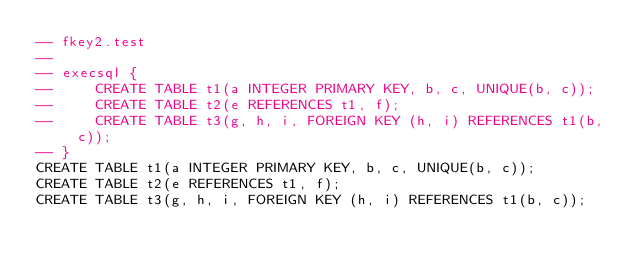<code> <loc_0><loc_0><loc_500><loc_500><_SQL_>-- fkey2.test
-- 
-- execsql {
--     CREATE TABLE t1(a INTEGER PRIMARY KEY, b, c, UNIQUE(b, c));
--     CREATE TABLE t2(e REFERENCES t1, f);
--     CREATE TABLE t3(g, h, i, FOREIGN KEY (h, i) REFERENCES t1(b, c));
-- }
CREATE TABLE t1(a INTEGER PRIMARY KEY, b, c, UNIQUE(b, c));
CREATE TABLE t2(e REFERENCES t1, f);
CREATE TABLE t3(g, h, i, FOREIGN KEY (h, i) REFERENCES t1(b, c));</code> 